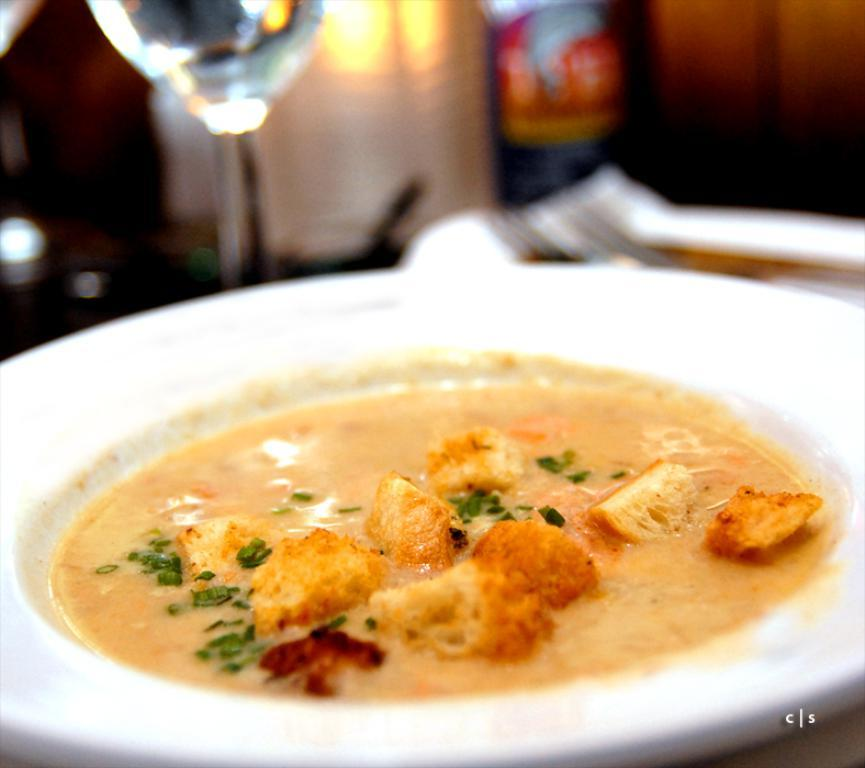What object is present on the plate in the image? The plate contains food. Can you describe the appearance of the background in the image? The background of the image appears blurry. Is there any additional information or marking on the image? Yes, there is a watermark on the image. How many ants can be seen carrying the food on the plate in the image? There are no ants present in the image, and the food on the plate is not being carried by any insects. 